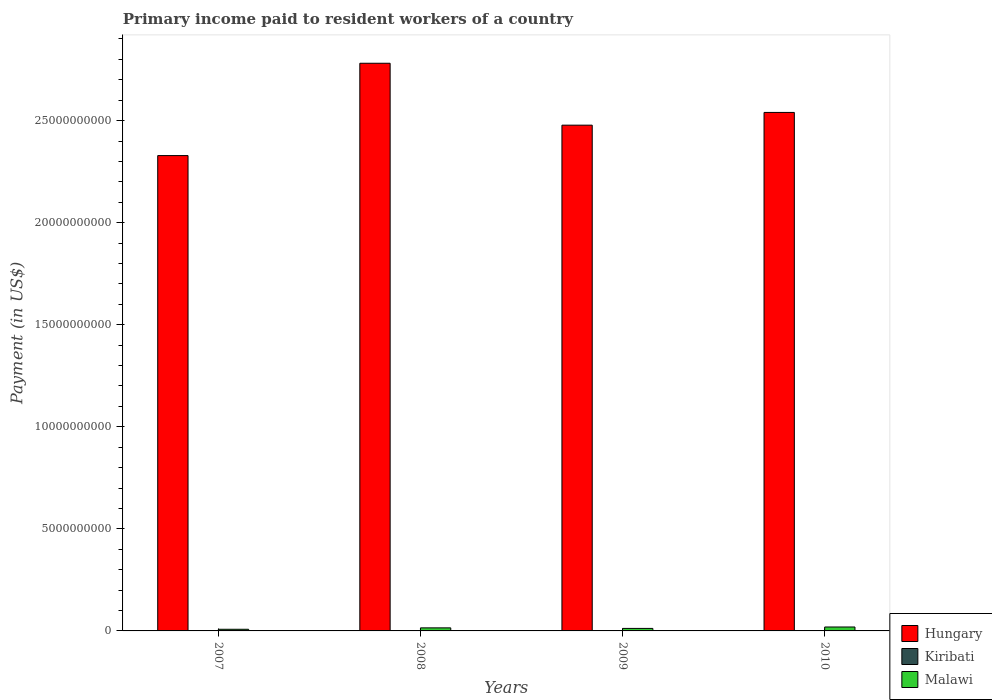How many groups of bars are there?
Provide a short and direct response. 4. Are the number of bars per tick equal to the number of legend labels?
Offer a very short reply. No. In how many cases, is the number of bars for a given year not equal to the number of legend labels?
Provide a short and direct response. 1. What is the amount paid to workers in Hungary in 2007?
Ensure brevity in your answer.  2.33e+1. Across all years, what is the maximum amount paid to workers in Hungary?
Provide a succinct answer. 2.78e+1. Across all years, what is the minimum amount paid to workers in Malawi?
Offer a very short reply. 8.07e+07. What is the total amount paid to workers in Hungary in the graph?
Your answer should be compact. 1.01e+11. What is the difference between the amount paid to workers in Hungary in 2009 and that in 2010?
Your response must be concise. -6.24e+08. What is the difference between the amount paid to workers in Malawi in 2008 and the amount paid to workers in Hungary in 2009?
Make the answer very short. -2.46e+1. What is the average amount paid to workers in Malawi per year?
Keep it short and to the point. 1.36e+08. In the year 2007, what is the difference between the amount paid to workers in Malawi and amount paid to workers in Kiribati?
Offer a terse response. 7.75e+07. What is the ratio of the amount paid to workers in Malawi in 2007 to that in 2008?
Provide a short and direct response. 0.54. Is the amount paid to workers in Malawi in 2007 less than that in 2010?
Your answer should be compact. Yes. Is the difference between the amount paid to workers in Malawi in 2007 and 2009 greater than the difference between the amount paid to workers in Kiribati in 2007 and 2009?
Provide a succinct answer. No. What is the difference between the highest and the second highest amount paid to workers in Kiribati?
Offer a terse response. 4.46e+05. What is the difference between the highest and the lowest amount paid to workers in Malawi?
Your answer should be compact. 1.12e+08. Is the sum of the amount paid to workers in Malawi in 2008 and 2010 greater than the maximum amount paid to workers in Kiribati across all years?
Provide a short and direct response. Yes. Are all the bars in the graph horizontal?
Provide a succinct answer. No. How many years are there in the graph?
Keep it short and to the point. 4. What is the difference between two consecutive major ticks on the Y-axis?
Your answer should be very brief. 5.00e+09. Does the graph contain any zero values?
Provide a short and direct response. Yes. Does the graph contain grids?
Offer a very short reply. No. What is the title of the graph?
Offer a very short reply. Primary income paid to resident workers of a country. Does "New Zealand" appear as one of the legend labels in the graph?
Your answer should be very brief. No. What is the label or title of the X-axis?
Offer a very short reply. Years. What is the label or title of the Y-axis?
Offer a terse response. Payment (in US$). What is the Payment (in US$) of Hungary in 2007?
Keep it short and to the point. 2.33e+1. What is the Payment (in US$) in Kiribati in 2007?
Ensure brevity in your answer.  3.27e+06. What is the Payment (in US$) of Malawi in 2007?
Offer a very short reply. 8.07e+07. What is the Payment (in US$) in Hungary in 2008?
Provide a short and direct response. 2.78e+1. What is the Payment (in US$) in Kiribati in 2008?
Your answer should be compact. 4.54e+06. What is the Payment (in US$) in Malawi in 2008?
Your answer should be very brief. 1.50e+08. What is the Payment (in US$) of Hungary in 2009?
Make the answer very short. 2.48e+1. What is the Payment (in US$) of Kiribati in 2009?
Your answer should be very brief. 4.10e+06. What is the Payment (in US$) in Malawi in 2009?
Make the answer very short. 1.23e+08. What is the Payment (in US$) of Hungary in 2010?
Offer a terse response. 2.54e+1. What is the Payment (in US$) of Malawi in 2010?
Your answer should be compact. 1.92e+08. Across all years, what is the maximum Payment (in US$) of Hungary?
Make the answer very short. 2.78e+1. Across all years, what is the maximum Payment (in US$) of Kiribati?
Keep it short and to the point. 4.54e+06. Across all years, what is the maximum Payment (in US$) in Malawi?
Your answer should be very brief. 1.92e+08. Across all years, what is the minimum Payment (in US$) in Hungary?
Your answer should be very brief. 2.33e+1. Across all years, what is the minimum Payment (in US$) in Kiribati?
Your answer should be very brief. 0. Across all years, what is the minimum Payment (in US$) in Malawi?
Provide a succinct answer. 8.07e+07. What is the total Payment (in US$) in Hungary in the graph?
Offer a terse response. 1.01e+11. What is the total Payment (in US$) in Kiribati in the graph?
Keep it short and to the point. 1.19e+07. What is the total Payment (in US$) of Malawi in the graph?
Offer a very short reply. 5.45e+08. What is the difference between the Payment (in US$) of Hungary in 2007 and that in 2008?
Your answer should be compact. -4.52e+09. What is the difference between the Payment (in US$) in Kiribati in 2007 and that in 2008?
Provide a short and direct response. -1.27e+06. What is the difference between the Payment (in US$) in Malawi in 2007 and that in 2008?
Make the answer very short. -6.90e+07. What is the difference between the Payment (in US$) of Hungary in 2007 and that in 2009?
Ensure brevity in your answer.  -1.49e+09. What is the difference between the Payment (in US$) in Kiribati in 2007 and that in 2009?
Your answer should be very brief. -8.27e+05. What is the difference between the Payment (in US$) of Malawi in 2007 and that in 2009?
Keep it short and to the point. -4.18e+07. What is the difference between the Payment (in US$) in Hungary in 2007 and that in 2010?
Your response must be concise. -2.11e+09. What is the difference between the Payment (in US$) in Malawi in 2007 and that in 2010?
Your answer should be compact. -1.12e+08. What is the difference between the Payment (in US$) of Hungary in 2008 and that in 2009?
Provide a succinct answer. 3.03e+09. What is the difference between the Payment (in US$) in Kiribati in 2008 and that in 2009?
Make the answer very short. 4.46e+05. What is the difference between the Payment (in US$) in Malawi in 2008 and that in 2009?
Your answer should be very brief. 2.73e+07. What is the difference between the Payment (in US$) in Hungary in 2008 and that in 2010?
Provide a succinct answer. 2.41e+09. What is the difference between the Payment (in US$) of Malawi in 2008 and that in 2010?
Make the answer very short. -4.25e+07. What is the difference between the Payment (in US$) of Hungary in 2009 and that in 2010?
Provide a succinct answer. -6.24e+08. What is the difference between the Payment (in US$) of Malawi in 2009 and that in 2010?
Keep it short and to the point. -6.97e+07. What is the difference between the Payment (in US$) of Hungary in 2007 and the Payment (in US$) of Kiribati in 2008?
Make the answer very short. 2.33e+1. What is the difference between the Payment (in US$) of Hungary in 2007 and the Payment (in US$) of Malawi in 2008?
Your answer should be very brief. 2.31e+1. What is the difference between the Payment (in US$) of Kiribati in 2007 and the Payment (in US$) of Malawi in 2008?
Provide a short and direct response. -1.47e+08. What is the difference between the Payment (in US$) in Hungary in 2007 and the Payment (in US$) in Kiribati in 2009?
Give a very brief answer. 2.33e+1. What is the difference between the Payment (in US$) in Hungary in 2007 and the Payment (in US$) in Malawi in 2009?
Your answer should be very brief. 2.32e+1. What is the difference between the Payment (in US$) in Kiribati in 2007 and the Payment (in US$) in Malawi in 2009?
Give a very brief answer. -1.19e+08. What is the difference between the Payment (in US$) of Hungary in 2007 and the Payment (in US$) of Malawi in 2010?
Your answer should be compact. 2.31e+1. What is the difference between the Payment (in US$) of Kiribati in 2007 and the Payment (in US$) of Malawi in 2010?
Provide a short and direct response. -1.89e+08. What is the difference between the Payment (in US$) of Hungary in 2008 and the Payment (in US$) of Kiribati in 2009?
Provide a short and direct response. 2.78e+1. What is the difference between the Payment (in US$) of Hungary in 2008 and the Payment (in US$) of Malawi in 2009?
Provide a short and direct response. 2.77e+1. What is the difference between the Payment (in US$) of Kiribati in 2008 and the Payment (in US$) of Malawi in 2009?
Your answer should be compact. -1.18e+08. What is the difference between the Payment (in US$) of Hungary in 2008 and the Payment (in US$) of Malawi in 2010?
Make the answer very short. 2.76e+1. What is the difference between the Payment (in US$) in Kiribati in 2008 and the Payment (in US$) in Malawi in 2010?
Provide a short and direct response. -1.88e+08. What is the difference between the Payment (in US$) in Hungary in 2009 and the Payment (in US$) in Malawi in 2010?
Your response must be concise. 2.46e+1. What is the difference between the Payment (in US$) in Kiribati in 2009 and the Payment (in US$) in Malawi in 2010?
Your response must be concise. -1.88e+08. What is the average Payment (in US$) of Hungary per year?
Your answer should be compact. 2.53e+1. What is the average Payment (in US$) of Kiribati per year?
Offer a terse response. 2.98e+06. What is the average Payment (in US$) of Malawi per year?
Make the answer very short. 1.36e+08. In the year 2007, what is the difference between the Payment (in US$) in Hungary and Payment (in US$) in Kiribati?
Provide a succinct answer. 2.33e+1. In the year 2007, what is the difference between the Payment (in US$) of Hungary and Payment (in US$) of Malawi?
Ensure brevity in your answer.  2.32e+1. In the year 2007, what is the difference between the Payment (in US$) of Kiribati and Payment (in US$) of Malawi?
Offer a terse response. -7.75e+07. In the year 2008, what is the difference between the Payment (in US$) of Hungary and Payment (in US$) of Kiribati?
Keep it short and to the point. 2.78e+1. In the year 2008, what is the difference between the Payment (in US$) of Hungary and Payment (in US$) of Malawi?
Provide a succinct answer. 2.77e+1. In the year 2008, what is the difference between the Payment (in US$) of Kiribati and Payment (in US$) of Malawi?
Make the answer very short. -1.45e+08. In the year 2009, what is the difference between the Payment (in US$) in Hungary and Payment (in US$) in Kiribati?
Make the answer very short. 2.48e+1. In the year 2009, what is the difference between the Payment (in US$) of Hungary and Payment (in US$) of Malawi?
Provide a succinct answer. 2.47e+1. In the year 2009, what is the difference between the Payment (in US$) of Kiribati and Payment (in US$) of Malawi?
Provide a succinct answer. -1.18e+08. In the year 2010, what is the difference between the Payment (in US$) in Hungary and Payment (in US$) in Malawi?
Offer a very short reply. 2.52e+1. What is the ratio of the Payment (in US$) in Hungary in 2007 to that in 2008?
Provide a short and direct response. 0.84. What is the ratio of the Payment (in US$) of Kiribati in 2007 to that in 2008?
Offer a very short reply. 0.72. What is the ratio of the Payment (in US$) in Malawi in 2007 to that in 2008?
Offer a terse response. 0.54. What is the ratio of the Payment (in US$) of Hungary in 2007 to that in 2009?
Provide a succinct answer. 0.94. What is the ratio of the Payment (in US$) of Kiribati in 2007 to that in 2009?
Provide a succinct answer. 0.8. What is the ratio of the Payment (in US$) of Malawi in 2007 to that in 2009?
Give a very brief answer. 0.66. What is the ratio of the Payment (in US$) in Hungary in 2007 to that in 2010?
Provide a succinct answer. 0.92. What is the ratio of the Payment (in US$) of Malawi in 2007 to that in 2010?
Give a very brief answer. 0.42. What is the ratio of the Payment (in US$) of Hungary in 2008 to that in 2009?
Give a very brief answer. 1.12. What is the ratio of the Payment (in US$) in Kiribati in 2008 to that in 2009?
Keep it short and to the point. 1.11. What is the ratio of the Payment (in US$) in Malawi in 2008 to that in 2009?
Make the answer very short. 1.22. What is the ratio of the Payment (in US$) of Hungary in 2008 to that in 2010?
Your answer should be compact. 1.09. What is the ratio of the Payment (in US$) of Malawi in 2008 to that in 2010?
Offer a terse response. 0.78. What is the ratio of the Payment (in US$) in Hungary in 2009 to that in 2010?
Your response must be concise. 0.98. What is the ratio of the Payment (in US$) in Malawi in 2009 to that in 2010?
Ensure brevity in your answer.  0.64. What is the difference between the highest and the second highest Payment (in US$) of Hungary?
Your answer should be compact. 2.41e+09. What is the difference between the highest and the second highest Payment (in US$) in Kiribati?
Offer a terse response. 4.46e+05. What is the difference between the highest and the second highest Payment (in US$) in Malawi?
Your answer should be very brief. 4.25e+07. What is the difference between the highest and the lowest Payment (in US$) in Hungary?
Give a very brief answer. 4.52e+09. What is the difference between the highest and the lowest Payment (in US$) of Kiribati?
Offer a very short reply. 4.54e+06. What is the difference between the highest and the lowest Payment (in US$) of Malawi?
Offer a very short reply. 1.12e+08. 